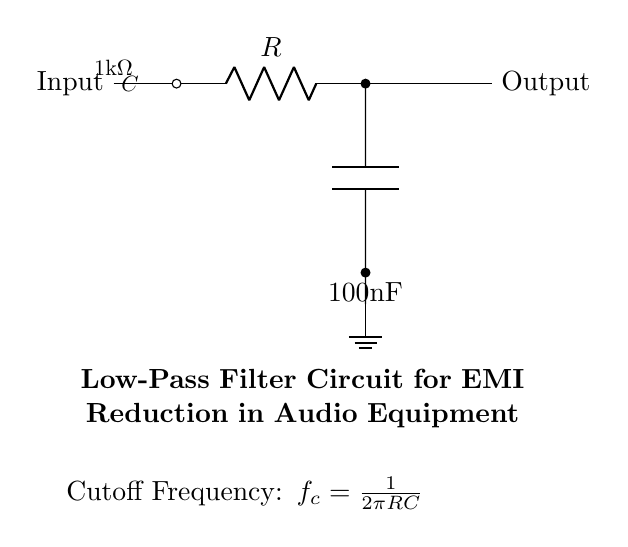What is the resistance value in the circuit? The resistance is indicated next to the resistor component in the circuit diagram. It shows 1kΩ clearly as labeled.
Answer: 1kΩ What is the capacitance value in the circuit? The capacitance value is shown alongside the capacitor in the circuit diagram. It is specified as 100nF, indicating the capacity of the capacitor.
Answer: 100nF What is the purpose of this circuit? The title in the diagram describes its primary function, which is to reduce electromagnetic interference in audio equipment. This suggests that the circuit filters out unwanted high-frequency signals.
Answer: Reduce electromagnetic interference What is the cutoff frequency formula used in this circuit? The formula is given in the circuit diagram directly under the title, showing the calculation method for the cutoff frequency based on resistance and capacitance values. It reads: fc = 1/(2πRC).
Answer: fc = 1/(2πRC) How does increasing the resistor value affect the cutoff frequency? Increasing the resistance will lead to a higher time constant in the RC circuit, lowering the cutoff frequency according to the formula provided in the circuit diagram. This means that lower frequencies will pass through, and high frequencies will be attenuated more.
Answer: Lowers cutoff frequency What is the relationship between resistance and capacitance in this circuit? The relationship is defined through the cutoff frequency formula shown, where the cutoff frequency is inversely proportional to the product of resistance and capacitance, meaning that increasing either will affect the filtering characteristics of the circuit.
Answer: Inversely proportional What will happen if the capacitance value decreases? If the capacitance decreases, the cutoff frequency will increase according to the formula, allowing higher frequencies to pass through and reducing the effectiveness of interference filtering.
Answer: Increases cutoff frequency 